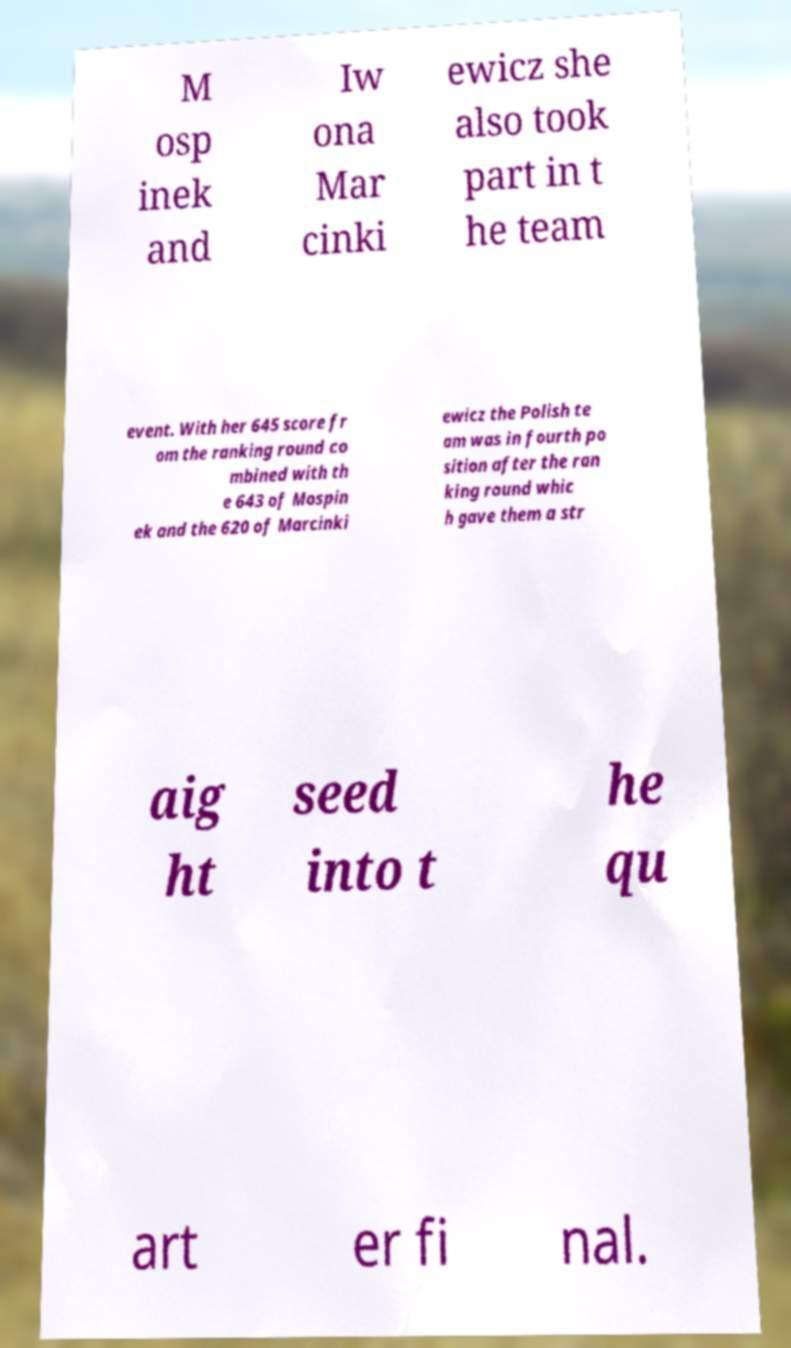Please identify and transcribe the text found in this image. M osp inek and Iw ona Mar cinki ewicz she also took part in t he team event. With her 645 score fr om the ranking round co mbined with th e 643 of Mospin ek and the 620 of Marcinki ewicz the Polish te am was in fourth po sition after the ran king round whic h gave them a str aig ht seed into t he qu art er fi nal. 